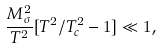Convert formula to latex. <formula><loc_0><loc_0><loc_500><loc_500>\frac { M _ { \sigma } ^ { 2 } } { T ^ { 2 } } [ T ^ { 2 } / T ^ { 2 } _ { c } - 1 ] \ll 1 ,</formula> 